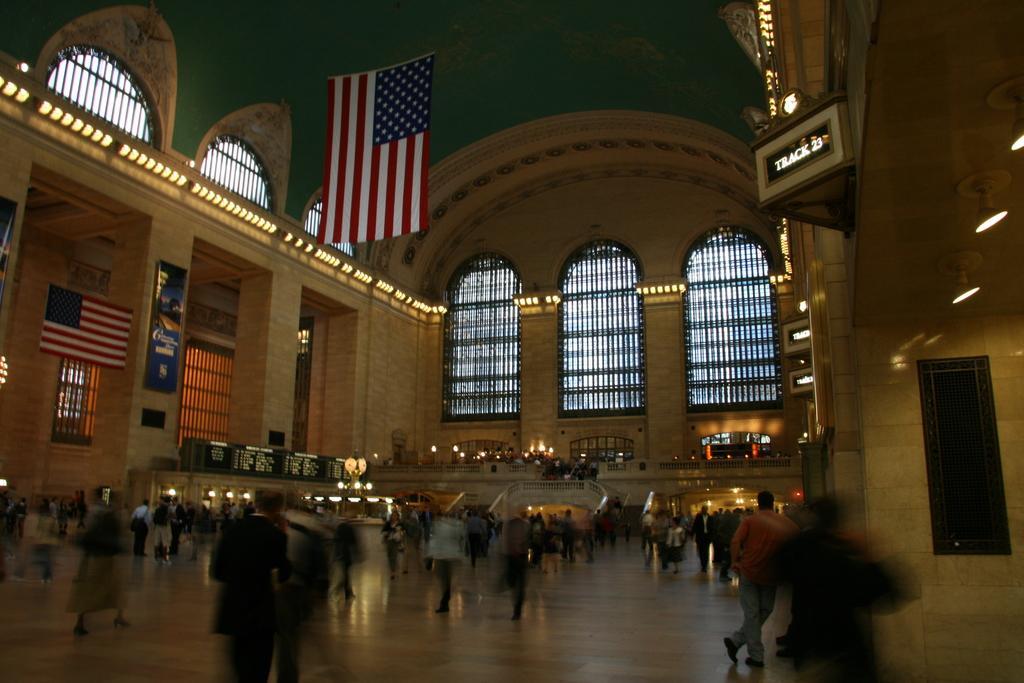How would you summarize this image in a sentence or two? This image is taken inside the hall where there are so many people standing on the floor. At the top there is a flag. In the middle there are lights. There are hoardings to the pillars. 